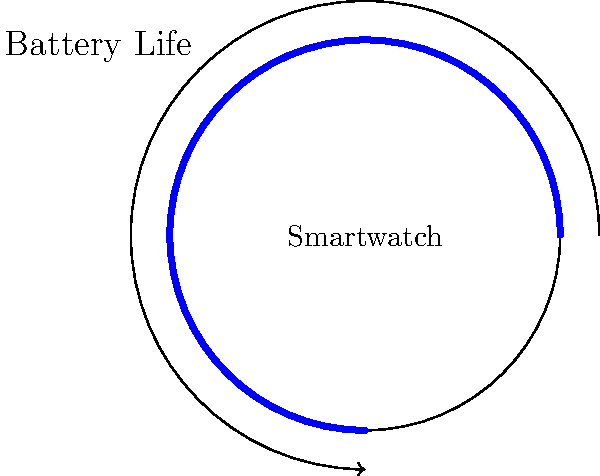A circular smartwatch has a face with a circumference of 12.56 cm. The battery life indicator on the watch face is represented by an arc that completes 75% of the full circle when fully charged. If the battery is currently at 60% charge, what is the length of the arc representing the current battery life? Let's approach this step-by-step:

1) First, we need to understand what 100% battery life represents:
   - 100% battery = 75% of the full circle
   - 75% of 360° = $0.75 \times 360° = 270°$

2) Now, let's calculate what 60% charge represents:
   - If 100% is 270°, then 60% is:
   - $60\% \text{ of } 270° = 0.60 \times 270° = 162°$

3) We know the circumference of the watch face is 12.56 cm.
   We can use the formula: $\text{Arc Length} = \frac{\theta}{360°} \times \text{Circumference}$
   Where $\theta$ is the central angle in degrees.

4) Plugging in our values:
   $\text{Arc Length} = \frac{162°}{360°} \times 12.56\text{ cm}$

5) Simplifying:
   $\text{Arc Length} = 0.45 \times 12.56\text{ cm} = 5.652\text{ cm}$

Therefore, the length of the arc representing 60% battery life is 5.652 cm.
Answer: 5.652 cm 